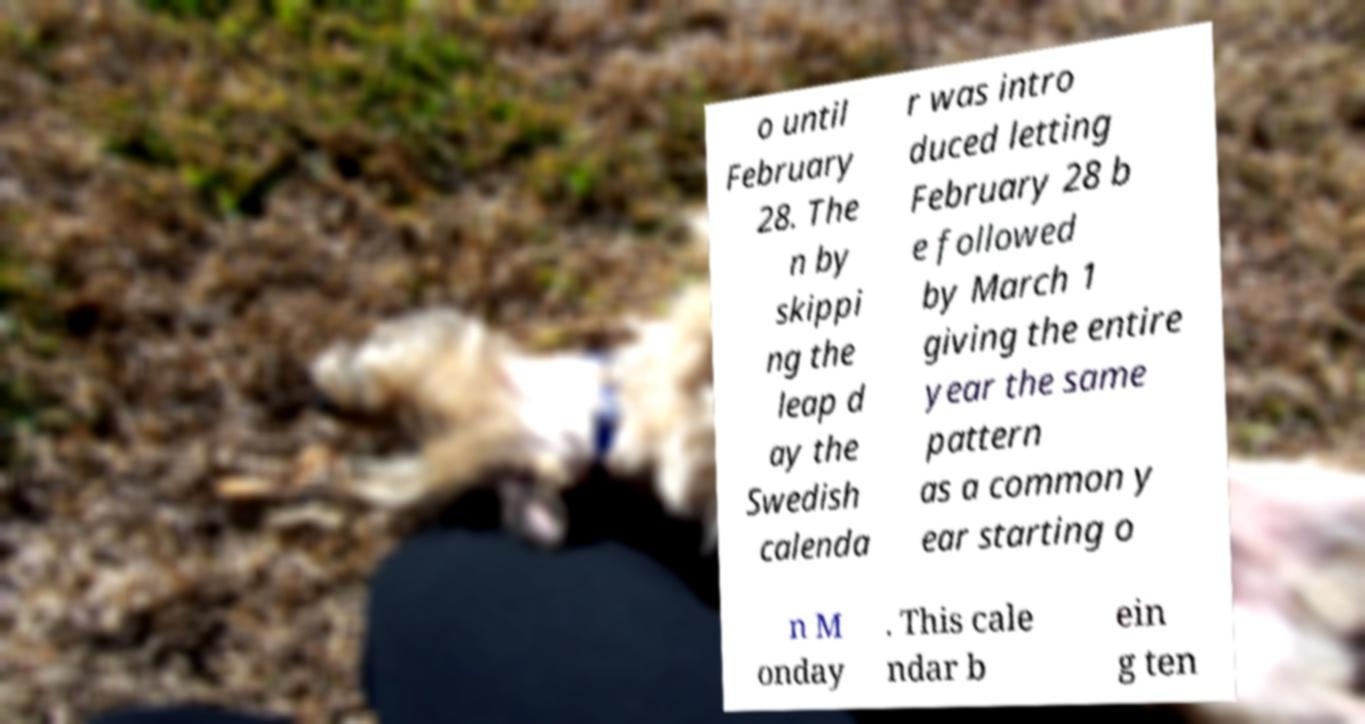Could you assist in decoding the text presented in this image and type it out clearly? o until February 28. The n by skippi ng the leap d ay the Swedish calenda r was intro duced letting February 28 b e followed by March 1 giving the entire year the same pattern as a common y ear starting o n M onday . This cale ndar b ein g ten 